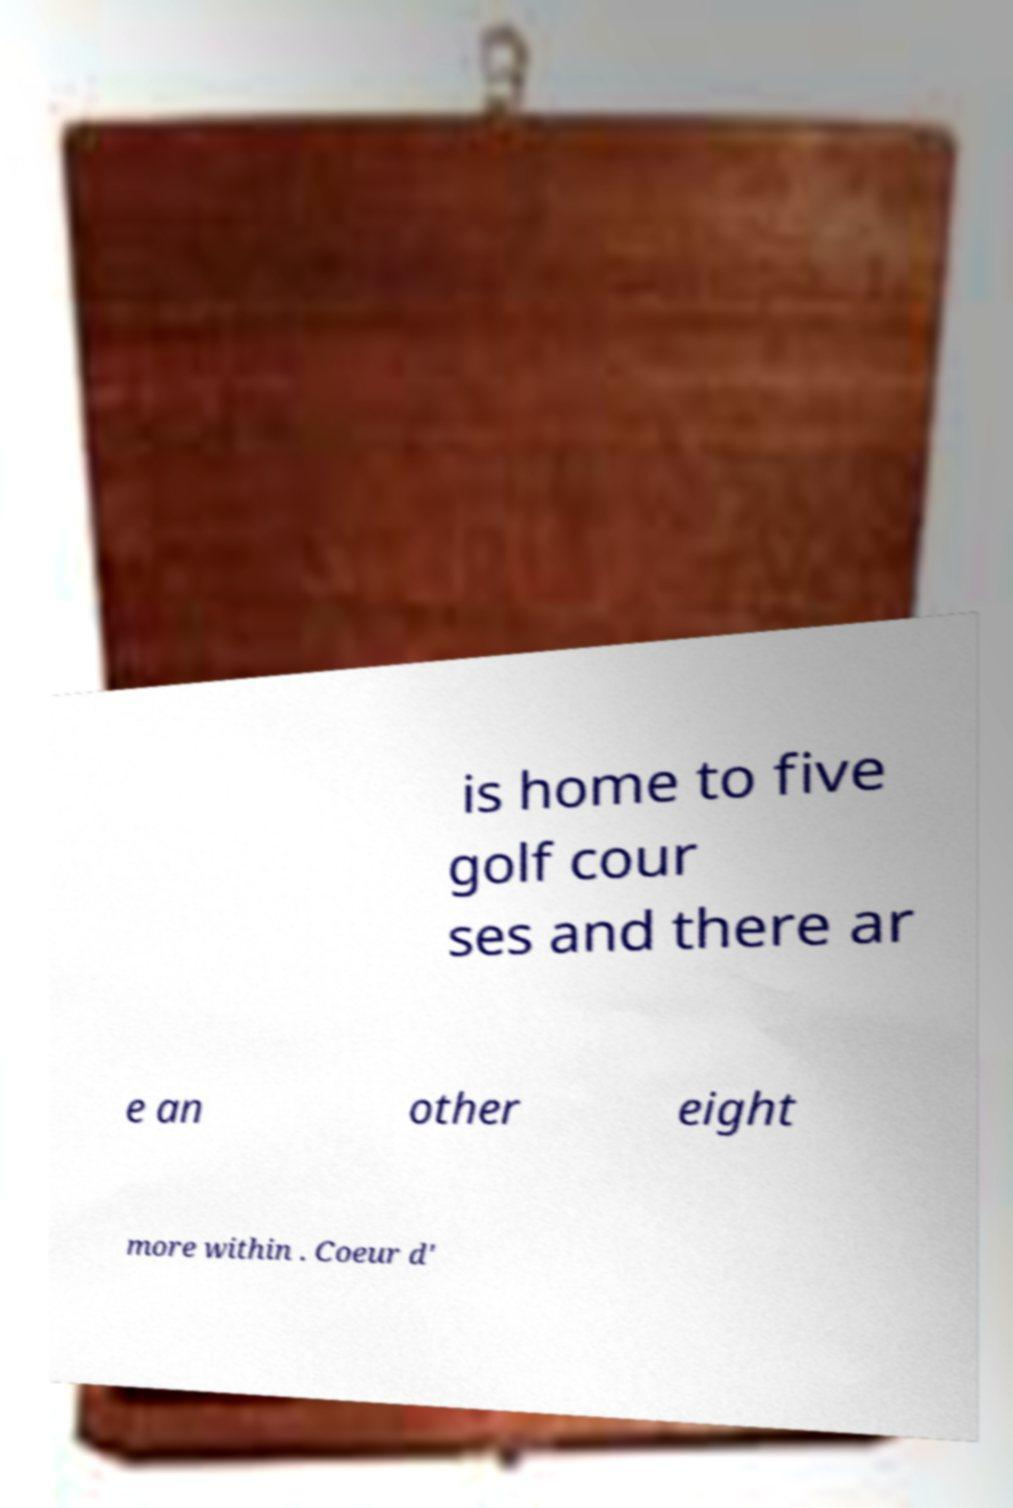Please identify and transcribe the text found in this image. is home to five golf cour ses and there ar e an other eight more within . Coeur d' 